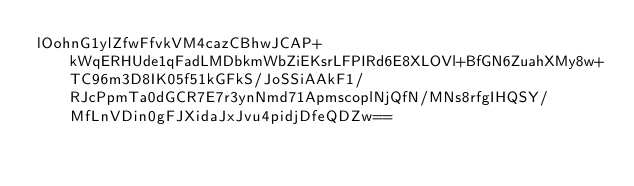<code> <loc_0><loc_0><loc_500><loc_500><_SML_>lOohnG1ylZfwFfvkVM4cazCBhwJCAP+kWqERHUde1qFadLMDbkmWbZiEKsrLFPIRd6E8XLOVl+BfGN6ZuahXMy8w+TC96m3D8IK05f51kGFkS/JoSSiAAkF1/RJcPpmTa0dGCR7E7r3ynNmd71ApmscoplNjQfN/MNs8rfgIHQSY/MfLnVDin0gFJXidaJxJvu4pidjDfeQDZw==</code> 